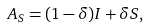Convert formula to latex. <formula><loc_0><loc_0><loc_500><loc_500>A _ { S } = ( 1 - \delta ) I + \delta S ,</formula> 